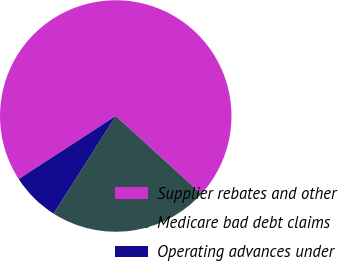Convert chart to OTSL. <chart><loc_0><loc_0><loc_500><loc_500><pie_chart><fcel>Supplier rebates and other<fcel>Medicare bad debt claims<fcel>Operating advances under<nl><fcel>70.94%<fcel>22.27%<fcel>6.8%<nl></chart> 